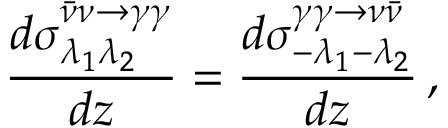<formula> <loc_0><loc_0><loc_500><loc_500>\frac { d { \sigma } _ { \lambda _ { 1 } \lambda _ { 2 } } ^ { \bar { \nu } \nu \to \gamma \gamma } } { d z } = \frac { d { \sigma } _ { - \lambda _ { 1 } - \lambda _ { 2 } } ^ { \gamma \gamma \to \nu \bar { \nu } } } { d z } \, ,</formula> 